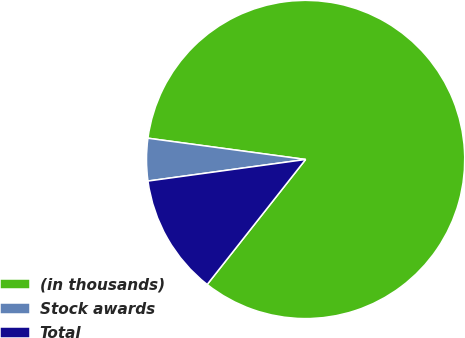Convert chart. <chart><loc_0><loc_0><loc_500><loc_500><pie_chart><fcel>(in thousands)<fcel>Stock awards<fcel>Total<nl><fcel>83.47%<fcel>4.3%<fcel>12.22%<nl></chart> 